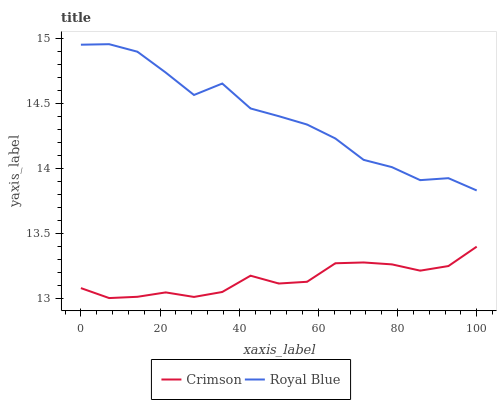Does Royal Blue have the minimum area under the curve?
Answer yes or no. No. Is Royal Blue the smoothest?
Answer yes or no. No. Does Royal Blue have the lowest value?
Answer yes or no. No. Is Crimson less than Royal Blue?
Answer yes or no. Yes. Is Royal Blue greater than Crimson?
Answer yes or no. Yes. Does Crimson intersect Royal Blue?
Answer yes or no. No. 